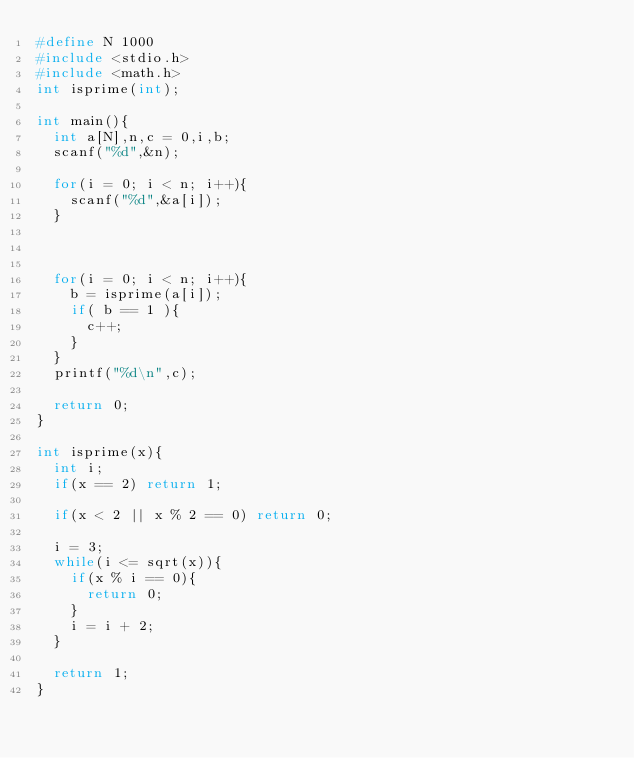<code> <loc_0><loc_0><loc_500><loc_500><_C_>#define N 1000
#include <stdio.h>
#include <math.h>
int isprime(int);

int main(){
  int a[N],n,c = 0,i,b;
  scanf("%d",&n);
  
  for(i = 0; i < n; i++){
    scanf("%d",&a[i]);
  }
  


  for(i = 0; i < n; i++){
    b = isprime(a[i]);
    if( b == 1 ){
      c++;
    }
  }
  printf("%d\n",c);

  return 0;
}

int isprime(x){
  int i;
  if(x == 2) return 1;

  if(x < 2 || x % 2 == 0) return 0;

  i = 3;
  while(i <= sqrt(x)){
    if(x % i == 0){
      return 0;
    }
    i = i + 2;
  }

  return 1;
}</code> 